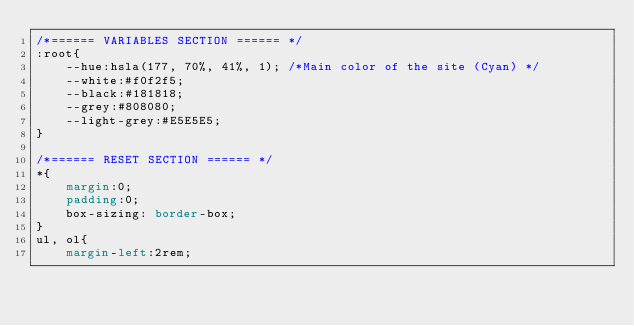<code> <loc_0><loc_0><loc_500><loc_500><_CSS_>/*====== VARIABLES SECTION ====== */
:root{
    --hue:hsla(177, 70%, 41%, 1); /*Main color of the site (Cyan) */
    --white:#f0f2f5; 
    --black:#181818;
    --grey:#808080;
    --light-grey:#E5E5E5;
}

/*====== RESET SECTION ====== */
*{
    margin:0;
    padding:0;
    box-sizing: border-box;
}
ul, ol{
    margin-left:2rem;</code> 